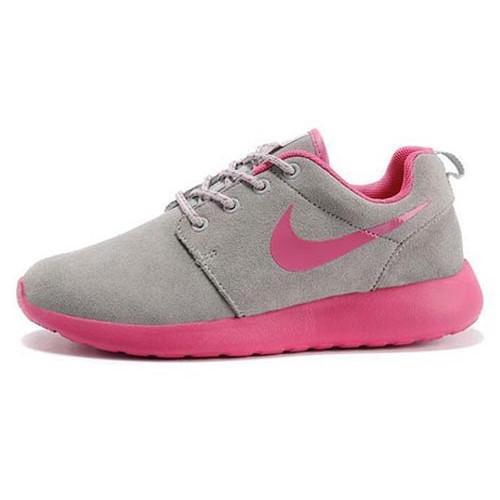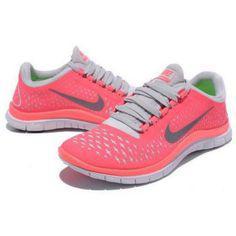The first image is the image on the left, the second image is the image on the right. Examine the images to the left and right. Is the description "All shoes feature hot pink and gray in their design, and all shoes have a curved boomerang-shaped logo on the side." accurate? Answer yes or no. Yes. The first image is the image on the left, the second image is the image on the right. Assess this claim about the two images: "In one image a shoe is flipped on its side.". Correct or not? Answer yes or no. No. 